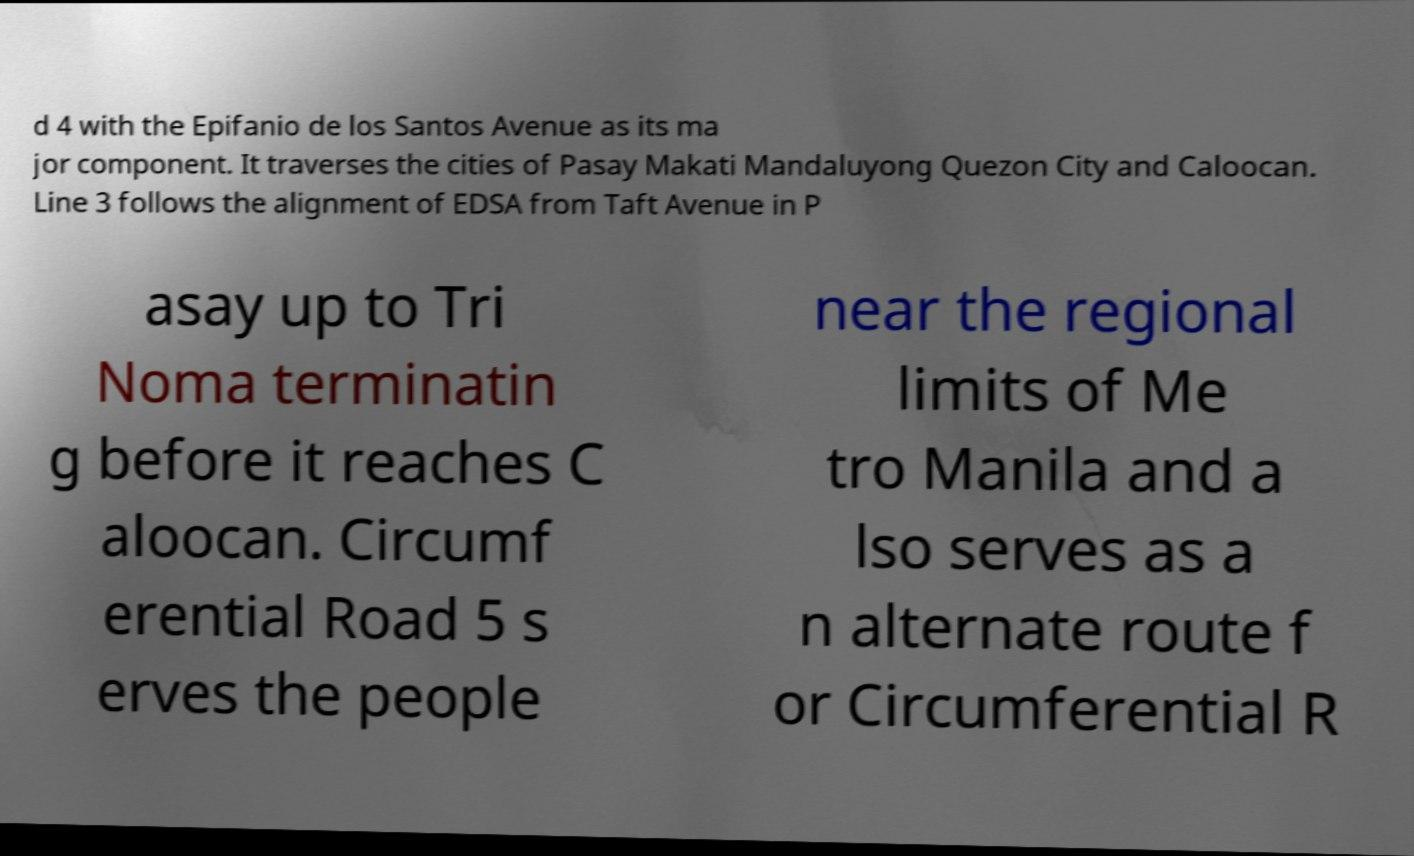Please identify and transcribe the text found in this image. d 4 with the Epifanio de los Santos Avenue as its ma jor component. It traverses the cities of Pasay Makati Mandaluyong Quezon City and Caloocan. Line 3 follows the alignment of EDSA from Taft Avenue in P asay up to Tri Noma terminatin g before it reaches C aloocan. Circumf erential Road 5 s erves the people near the regional limits of Me tro Manila and a lso serves as a n alternate route f or Circumferential R 